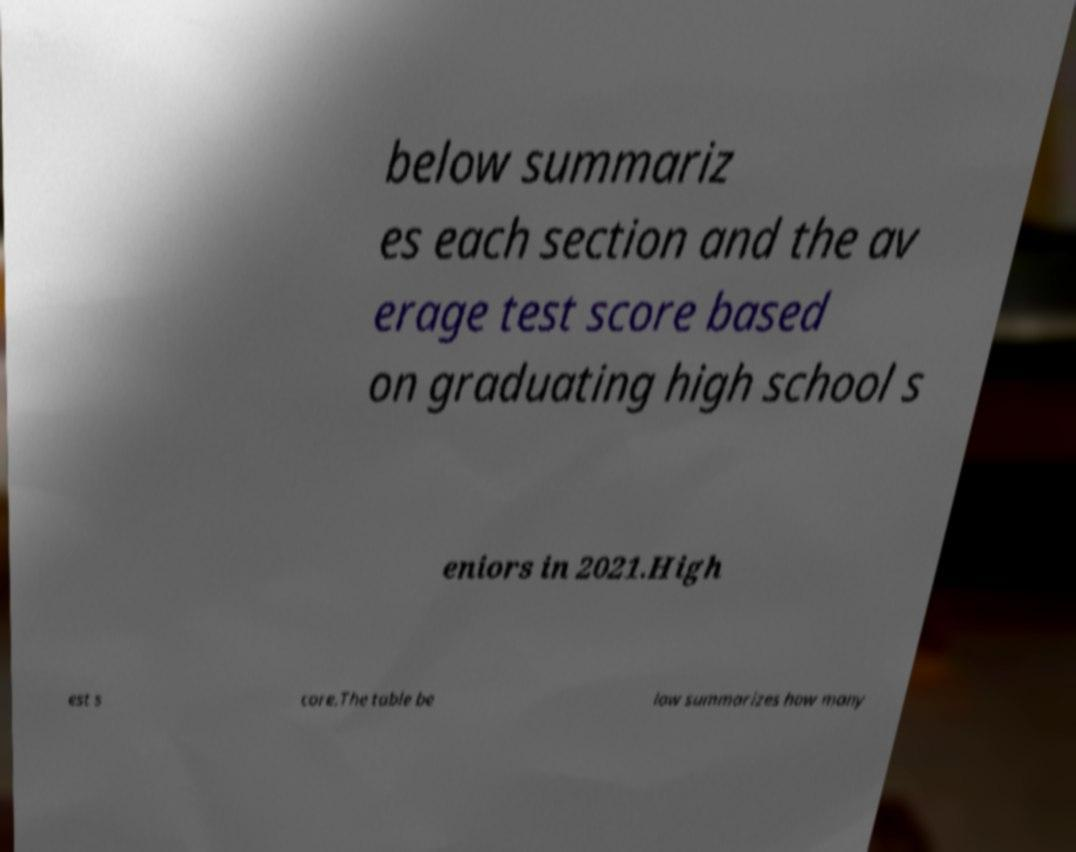Can you accurately transcribe the text from the provided image for me? below summariz es each section and the av erage test score based on graduating high school s eniors in 2021.High est s core.The table be low summarizes how many 